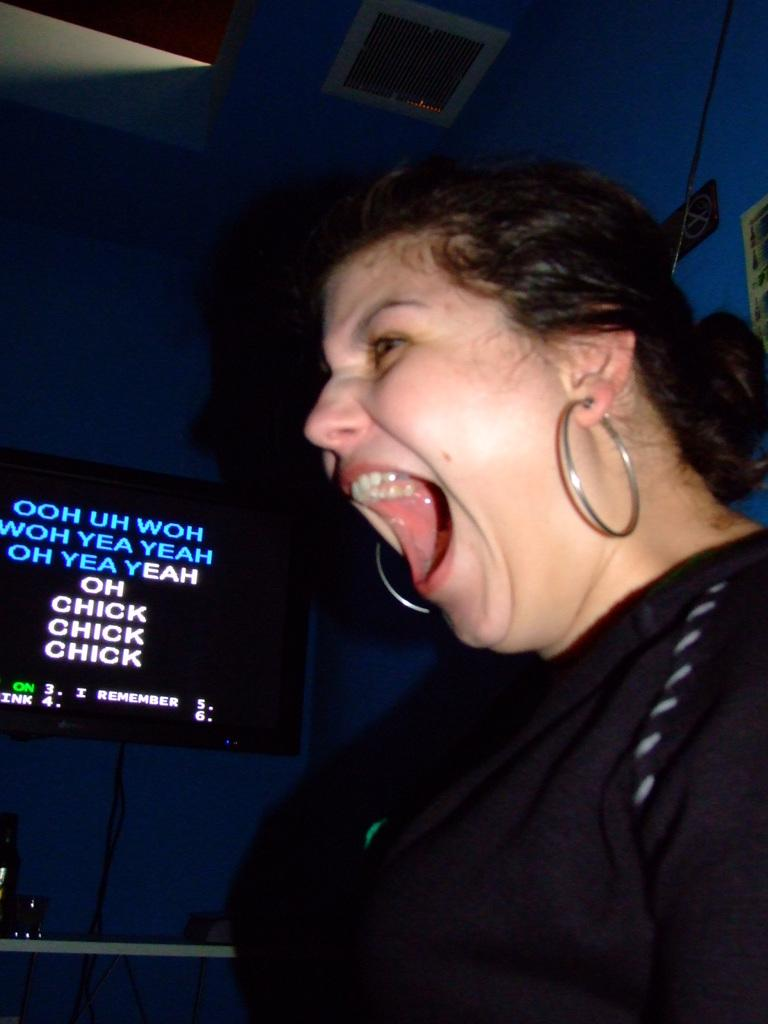Who or what is present in the image? There is a person in the image. What is the person doing in the image? The person's mouth is open. What is the person wearing in the image? The person is wearing a black dress. What other object can be seen in the image? There is a television in the image. What type of ticket is the person holding in the image? There is no ticket present in the image. What is the person's reaction to the protest in the image? There is no protest or indication of a reaction to one in the image. 